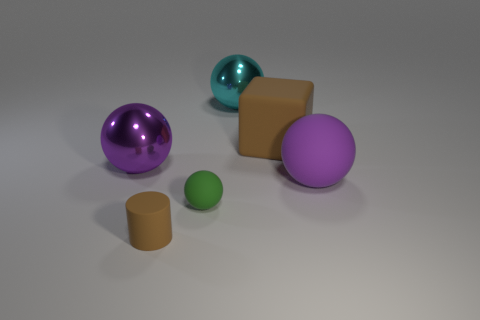Add 2 brown rubber cylinders. How many objects exist? 8 Subtract all spheres. How many objects are left? 2 Subtract all brown matte things. Subtract all small metallic blocks. How many objects are left? 4 Add 1 small cylinders. How many small cylinders are left? 2 Add 3 big gray metallic blocks. How many big gray metallic blocks exist? 3 Subtract 0 gray cubes. How many objects are left? 6 